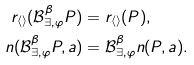<formula> <loc_0><loc_0><loc_500><loc_500>r _ { \langle \rangle } ( \mathcal { B } _ { \exists , \varphi } ^ { \beta } P ) & = r _ { \langle \rangle } ( P ) , \\ n ( \mathcal { B } _ { \exists , \varphi } ^ { \beta } P , a ) & = \mathcal { B } _ { \exists , \varphi } ^ { \beta } n ( P , a ) .</formula> 